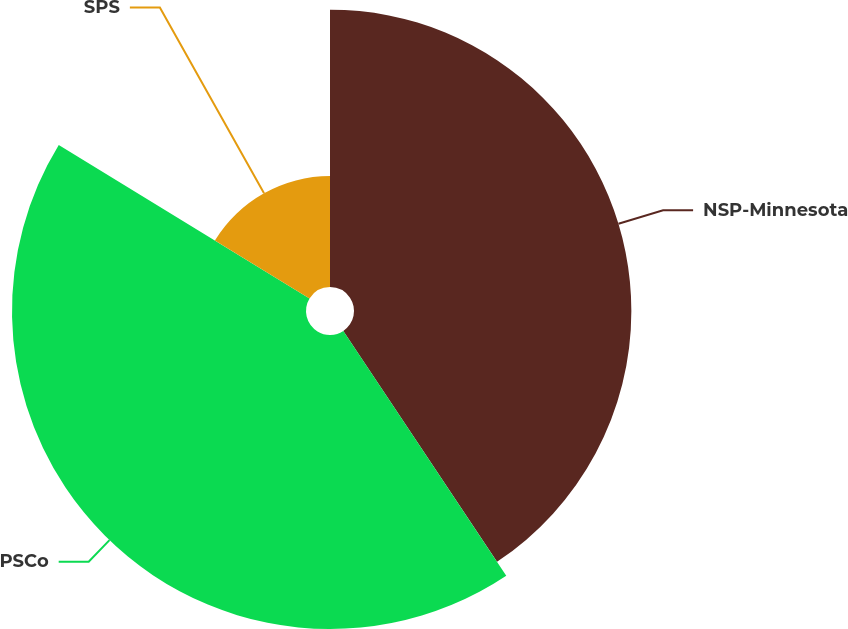Convert chart. <chart><loc_0><loc_0><loc_500><loc_500><pie_chart><fcel>NSP-Minnesota<fcel>PSCo<fcel>SPS<nl><fcel>40.65%<fcel>43.09%<fcel>16.26%<nl></chart> 